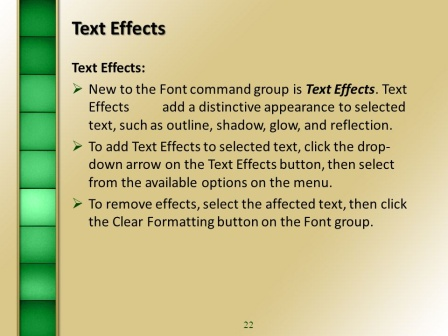How is the organization of this slide beneficial for its audience? The organization of this slide is highly beneficial for its audience due to its clear and concise format. The title at the top immediately informs viewers of the topic, while the bullet points break down the information into manageable chunks, making it easier to follow and understand. The use of space and design elements like the vertical gradient bar helps maintain visual interest and ensures that the slide is not overly cluttered. Additionally, the slide number provides context within the larger presentation, helping the audience to orient themselves and anticipate the flow of the content.  In what scenarios might using these text effects be particularly advantageous in a business presentation? Using text effects in a business presentation can be particularly advantageous in several scenarios:
- **Highlighting Key Points:** Effects like bold outlines or reflections can draw attention to essential information or key takeaways, ensuring that the audience remembers these points.
- **Differentiating Sections:** Text effects can help distinguish between different sections or topics within a presentation, making it easier for viewers to follow the structure and flow.
- **Emphasizing Data:** When presenting data or statistics, using shadow or glow effects can make these figures stand out, emphasizing their importance.
- **Enhancing Aesthetics:** Professionally applied text effects can make a presentation visually appealing, potentially keeping the audience more engaged and interested.
- **Branding:** Consistent use of certain effects that align with the company’s branding can reinforce brand identity throughout the presentation.  What might the next slide in this presentation be about? The next slide in this presentation might delve into more advanced text formatting options or perhaps transition to discussing graphical elements that can be incorporated into presentations. Given the detailed nature of the current slide on text effects, a logical progression could include how to combine text effects with images or charts to create more engaging slides. Another possibility is a slide about animations and transitions, offering tips on how to animate text or other slide elements to enhance the flow and engagement of the presentation. 